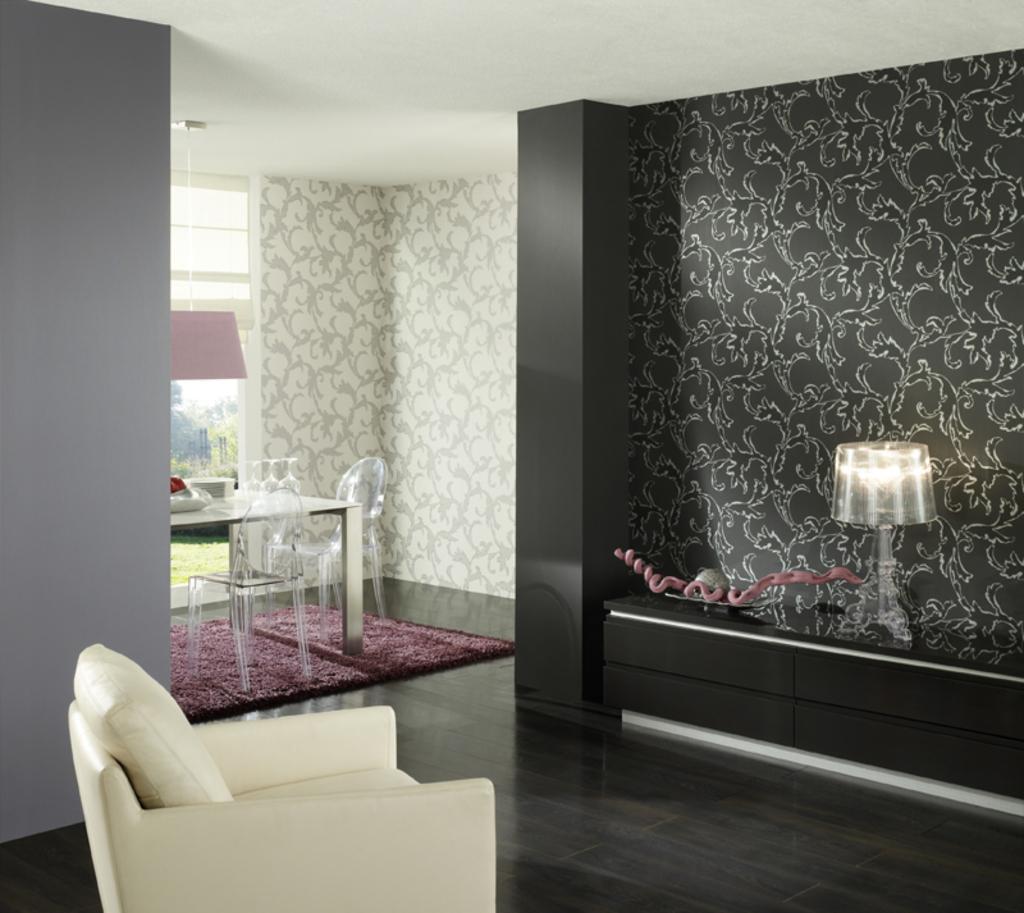In one or two sentences, can you explain what this image depicts? In the picture we can find the house, and we find a chair inside the house and we can find a dining table placed on the mat and two chairs, on the table we can find three glasses, bowl and tissues and we can also find the window and a well designed and ceiling we can see the lamp and one lamp is placed on the desk. 